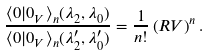Convert formula to latex. <formula><loc_0><loc_0><loc_500><loc_500>\frac { \langle 0 | 0 _ { V } \rangle _ { n } ( \lambda _ { 2 } , \lambda _ { 0 } ) } { \langle 0 | 0 _ { V } \rangle _ { n } ( { \lambda } ^ { \prime } _ { 2 } , { \lambda } ^ { \prime } _ { 0 } ) } = \frac { 1 } { n ! } \left ( R V \right ) ^ { n } .</formula> 